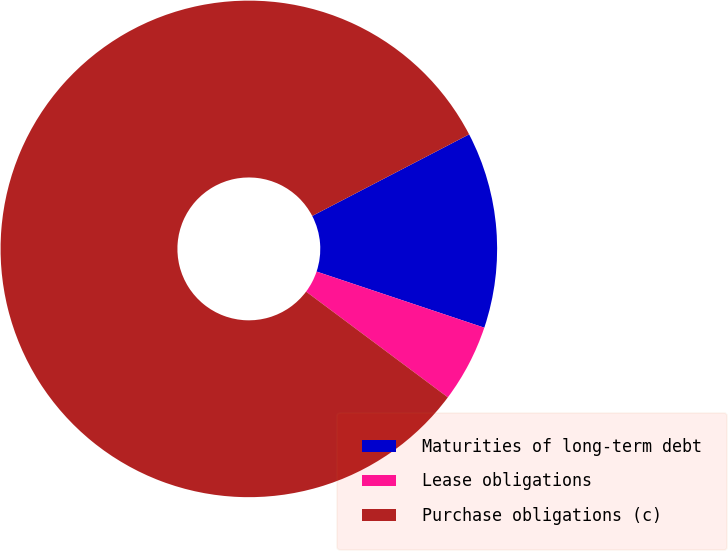Convert chart. <chart><loc_0><loc_0><loc_500><loc_500><pie_chart><fcel>Maturities of long-term debt<fcel>Lease obligations<fcel>Purchase obligations (c)<nl><fcel>12.77%<fcel>5.06%<fcel>82.16%<nl></chart> 